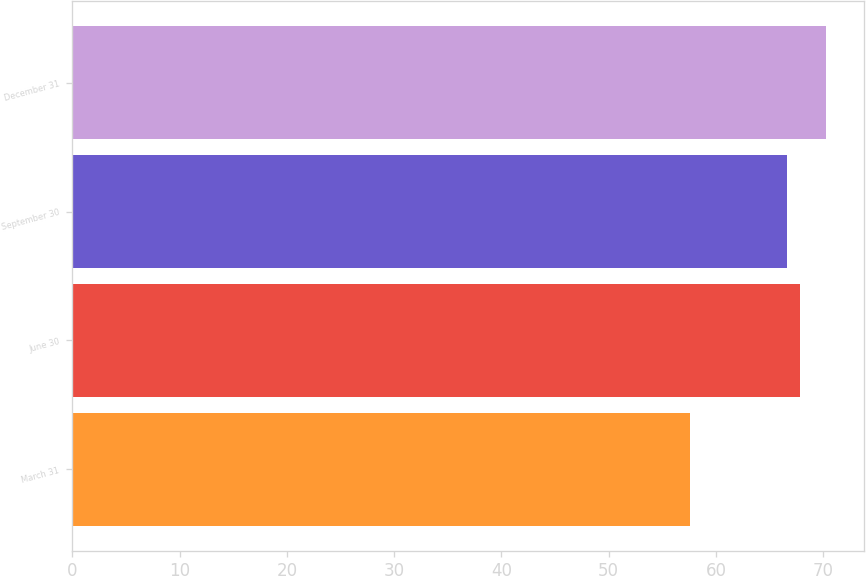Convert chart to OTSL. <chart><loc_0><loc_0><loc_500><loc_500><bar_chart><fcel>March 31<fcel>June 30<fcel>September 30<fcel>December 31<nl><fcel>57.6<fcel>67.88<fcel>66.61<fcel>70.27<nl></chart> 